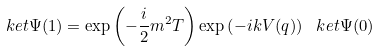Convert formula to latex. <formula><loc_0><loc_0><loc_500><loc_500>\ k e t { \Psi ( 1 ) } = \exp \left ( - \frac { i } { 2 } m ^ { 2 } T \right ) \exp \left ( - i k V ( q ) \right ) \ k e t { \Psi ( 0 ) }</formula> 